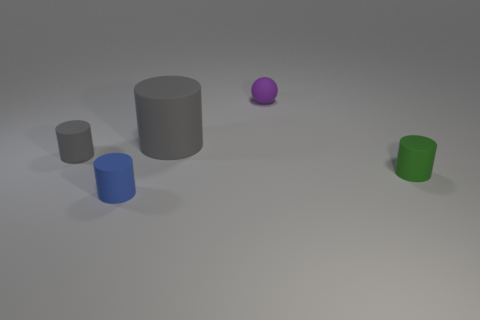Subtract all yellow cylinders. Subtract all cyan blocks. How many cylinders are left? 4 Add 1 tiny gray rubber things. How many objects exist? 6 Subtract all balls. How many objects are left? 4 Subtract all large gray matte objects. Subtract all tiny green matte objects. How many objects are left? 3 Add 2 small matte balls. How many small matte balls are left? 3 Add 1 blue cylinders. How many blue cylinders exist? 2 Subtract 0 cyan blocks. How many objects are left? 5 